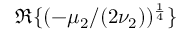<formula> <loc_0><loc_0><loc_500><loc_500>\mathfrak { R } \{ ( - \mu _ { 2 } / ( 2 \nu _ { 2 } ) ) ^ { \frac { 1 } { 4 } } \}</formula> 